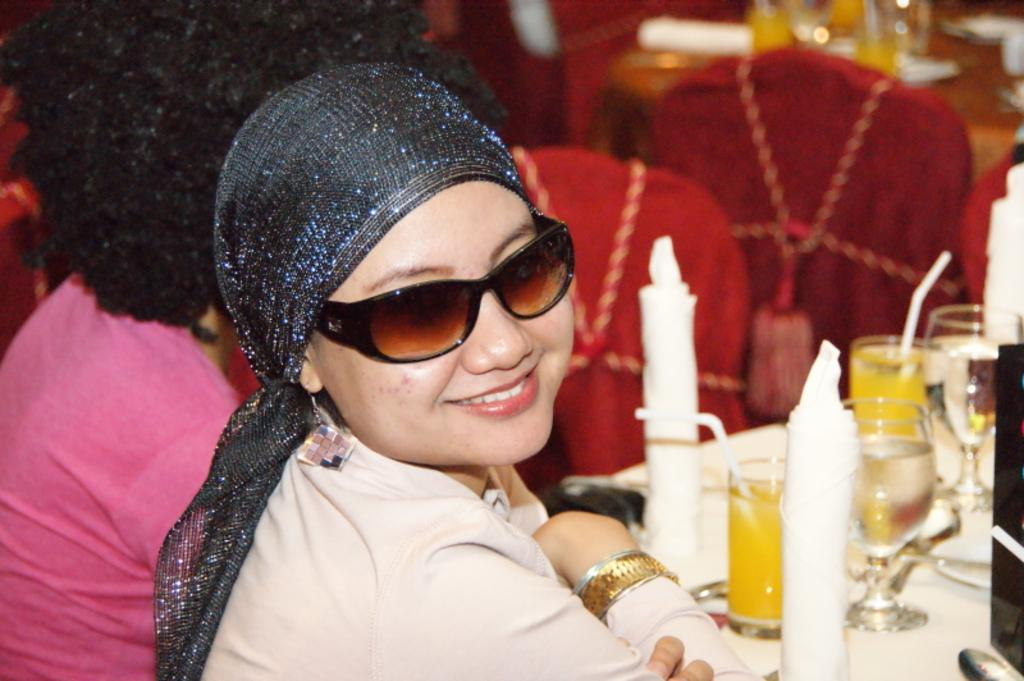Who is the main subject in the image? There is a woman in the image. What is the woman doing in the image? The woman is in front of a table. What can be seen on the table? There are objects placed on the table. Can you describe the setting behind the woman? There are people visible behind the woman, as well as chairs, tables, and other objects in the background. What type of question is the woman asking in the image? There is no indication in the image that the woman is asking a question. Who is the creator of the objects visible on the table? The image does not provide information about the creator of the objects on the table. Is there any water visible in the image? There is no water visible in the image. 